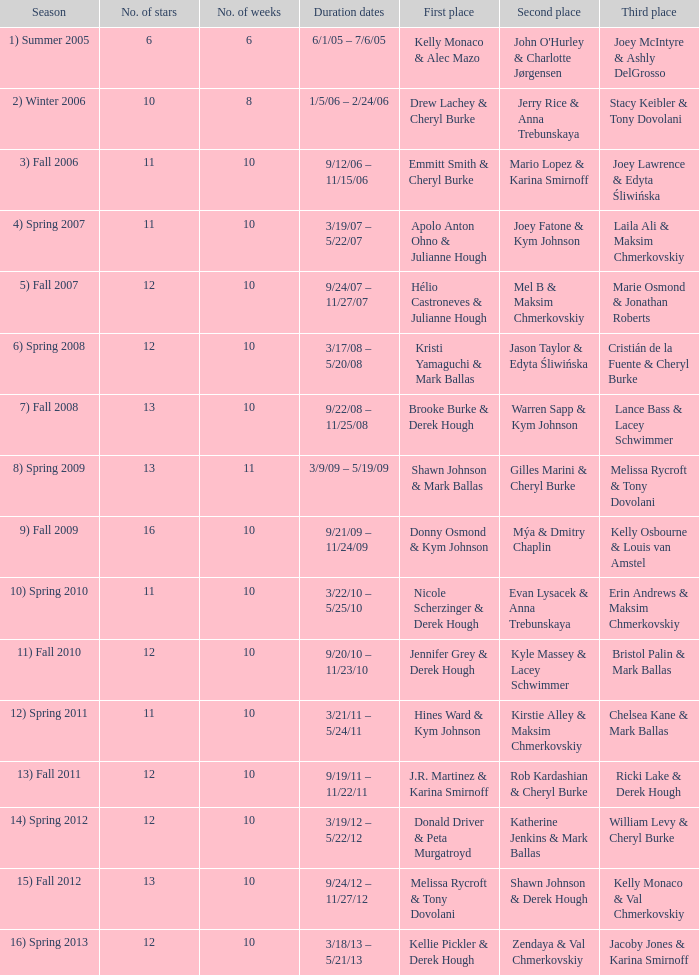Who took first place in week 6? 1.0. 